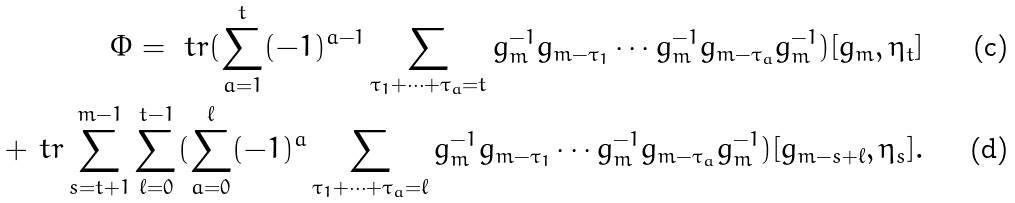Convert formula to latex. <formula><loc_0><loc_0><loc_500><loc_500>\Phi = \ t r ( \sum _ { a = 1 } ^ { t } ( - 1 ) ^ { a - 1 } \sum _ { \tau _ { 1 } + \dots + \tau _ { a } = t } g _ { m } ^ { - 1 } g _ { m - \tau _ { 1 } } \cdots g _ { m } ^ { - 1 } g _ { m - \tau _ { a } } g _ { m } ^ { - 1 } ) [ g _ { m } , \eta _ { t } ] \\ + \ t r \sum _ { s = t + 1 } ^ { m - 1 } \sum _ { \ell = 0 } ^ { t - 1 } ( \sum _ { a = 0 } ^ { \ell } ( - 1 ) ^ { a } \sum _ { \tau _ { 1 } + \dots + \tau _ { a } = \ell } g _ { m } ^ { - 1 } g _ { m - \tau _ { 1 } } \cdots g _ { m } ^ { - 1 } g _ { m - \tau _ { a } } g _ { m } ^ { - 1 } ) [ g _ { m - s + \ell } , \eta _ { s } ] .</formula> 